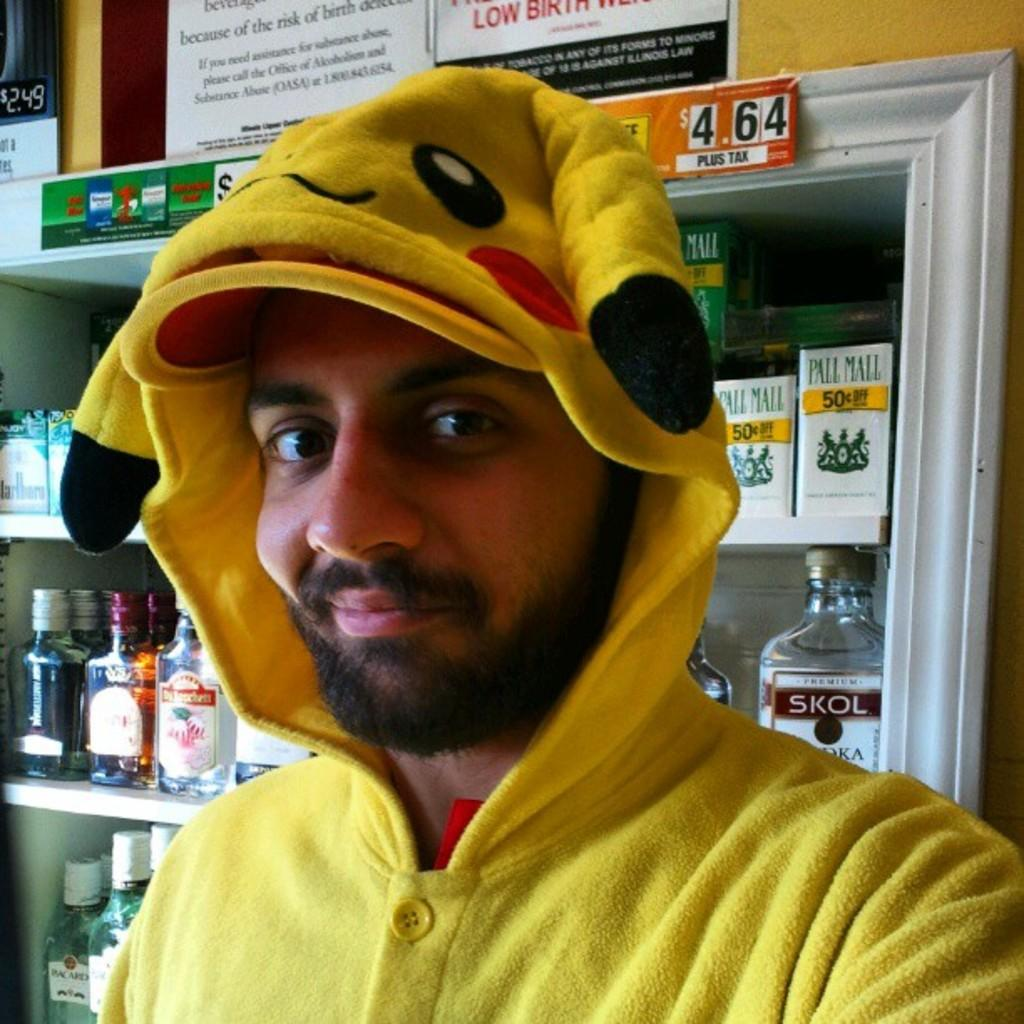What is the main subject of the image? There is a man standing in the image. What is the man wearing in the image? The man is wearing a jacket. Can you describe the color of the jacket? The jacket has a yellow color. What can be seen in the background of the image? There are racks with bottles in the background of the image. How many babies are being held by the man in the image? There are no babies present in the image; it features a man wearing a yellow jacket. What type of authority figure is depicted in the image? There is no authority figure depicted in the image; it only shows a man wearing a yellow jacket and racks with bottles in the background. 